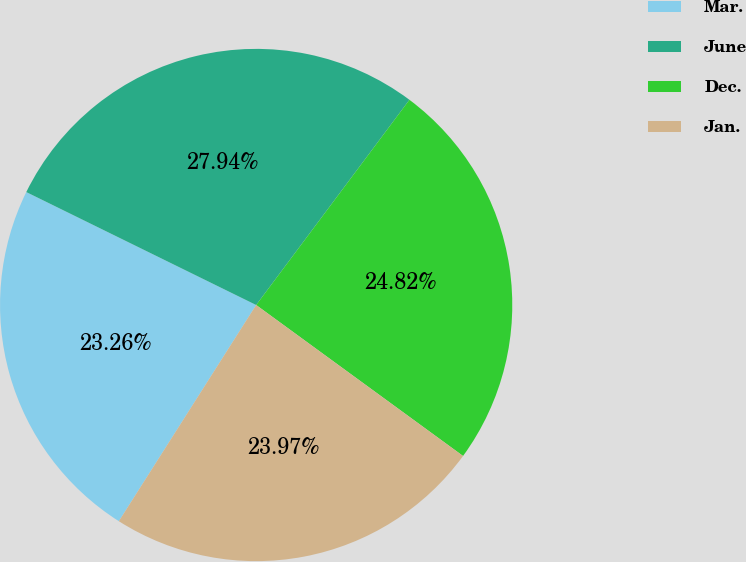Convert chart to OTSL. <chart><loc_0><loc_0><loc_500><loc_500><pie_chart><fcel>Mar.<fcel>June<fcel>Dec.<fcel>Jan.<nl><fcel>23.26%<fcel>27.94%<fcel>24.82%<fcel>23.97%<nl></chart> 